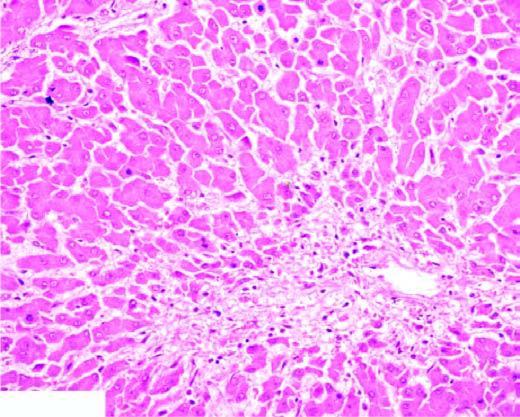does the peripheral zone show mild fatty change of liver cells?
Answer the question using a single word or phrase. Yes 